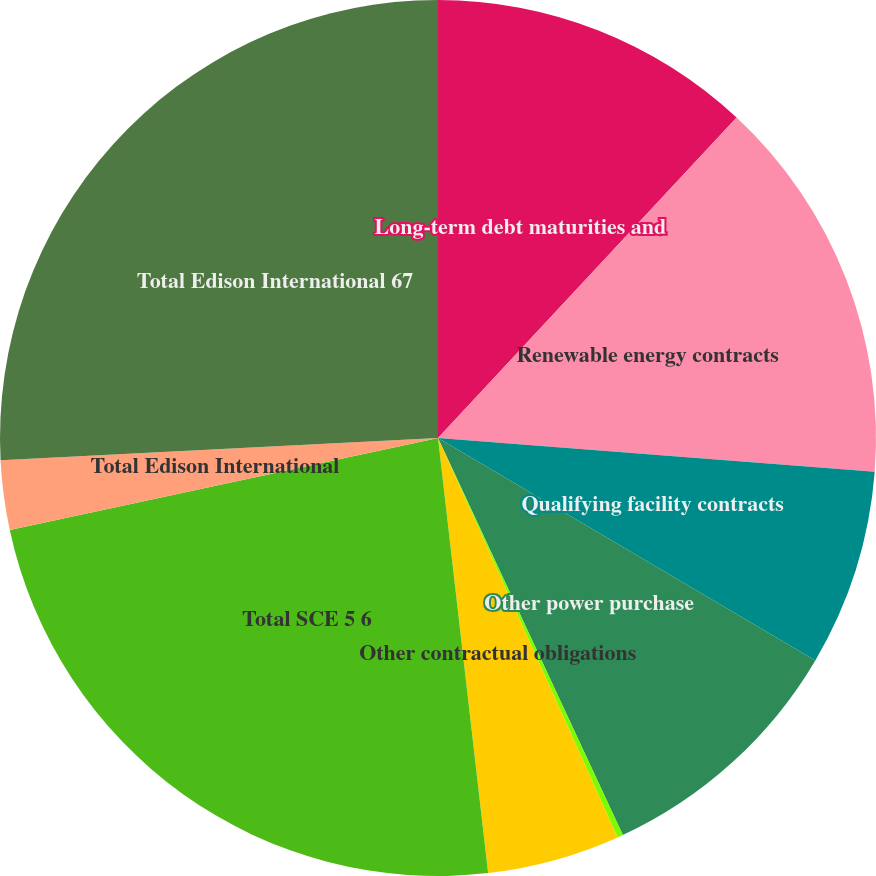<chart> <loc_0><loc_0><loc_500><loc_500><pie_chart><fcel>Long-term debt maturities and<fcel>Renewable energy contracts<fcel>Qualifying facility contracts<fcel>Other power purchase<fcel>Other operating lease<fcel>Other contractual obligations<fcel>Total SCE 5 6<fcel>Total Edison International<fcel>Total Edison International 67<nl><fcel>11.94%<fcel>14.29%<fcel>7.25%<fcel>9.59%<fcel>0.21%<fcel>4.9%<fcel>23.46%<fcel>2.56%<fcel>25.81%<nl></chart> 